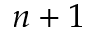Convert formula to latex. <formula><loc_0><loc_0><loc_500><loc_500>n + 1</formula> 